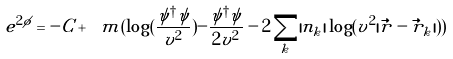<formula> <loc_0><loc_0><loc_500><loc_500>e ^ { 2 \phi } = - C + \ m ( \log ( \frac { \psi ^ { \dagger } \psi } { v ^ { 2 } } ) - \frac { \psi ^ { \dagger } \psi } { 2 v ^ { 2 } } - 2 \sum _ { k } | n _ { k } | \log ( v ^ { 2 } | \vec { r } - \vec { r } _ { k } | ) )</formula> 